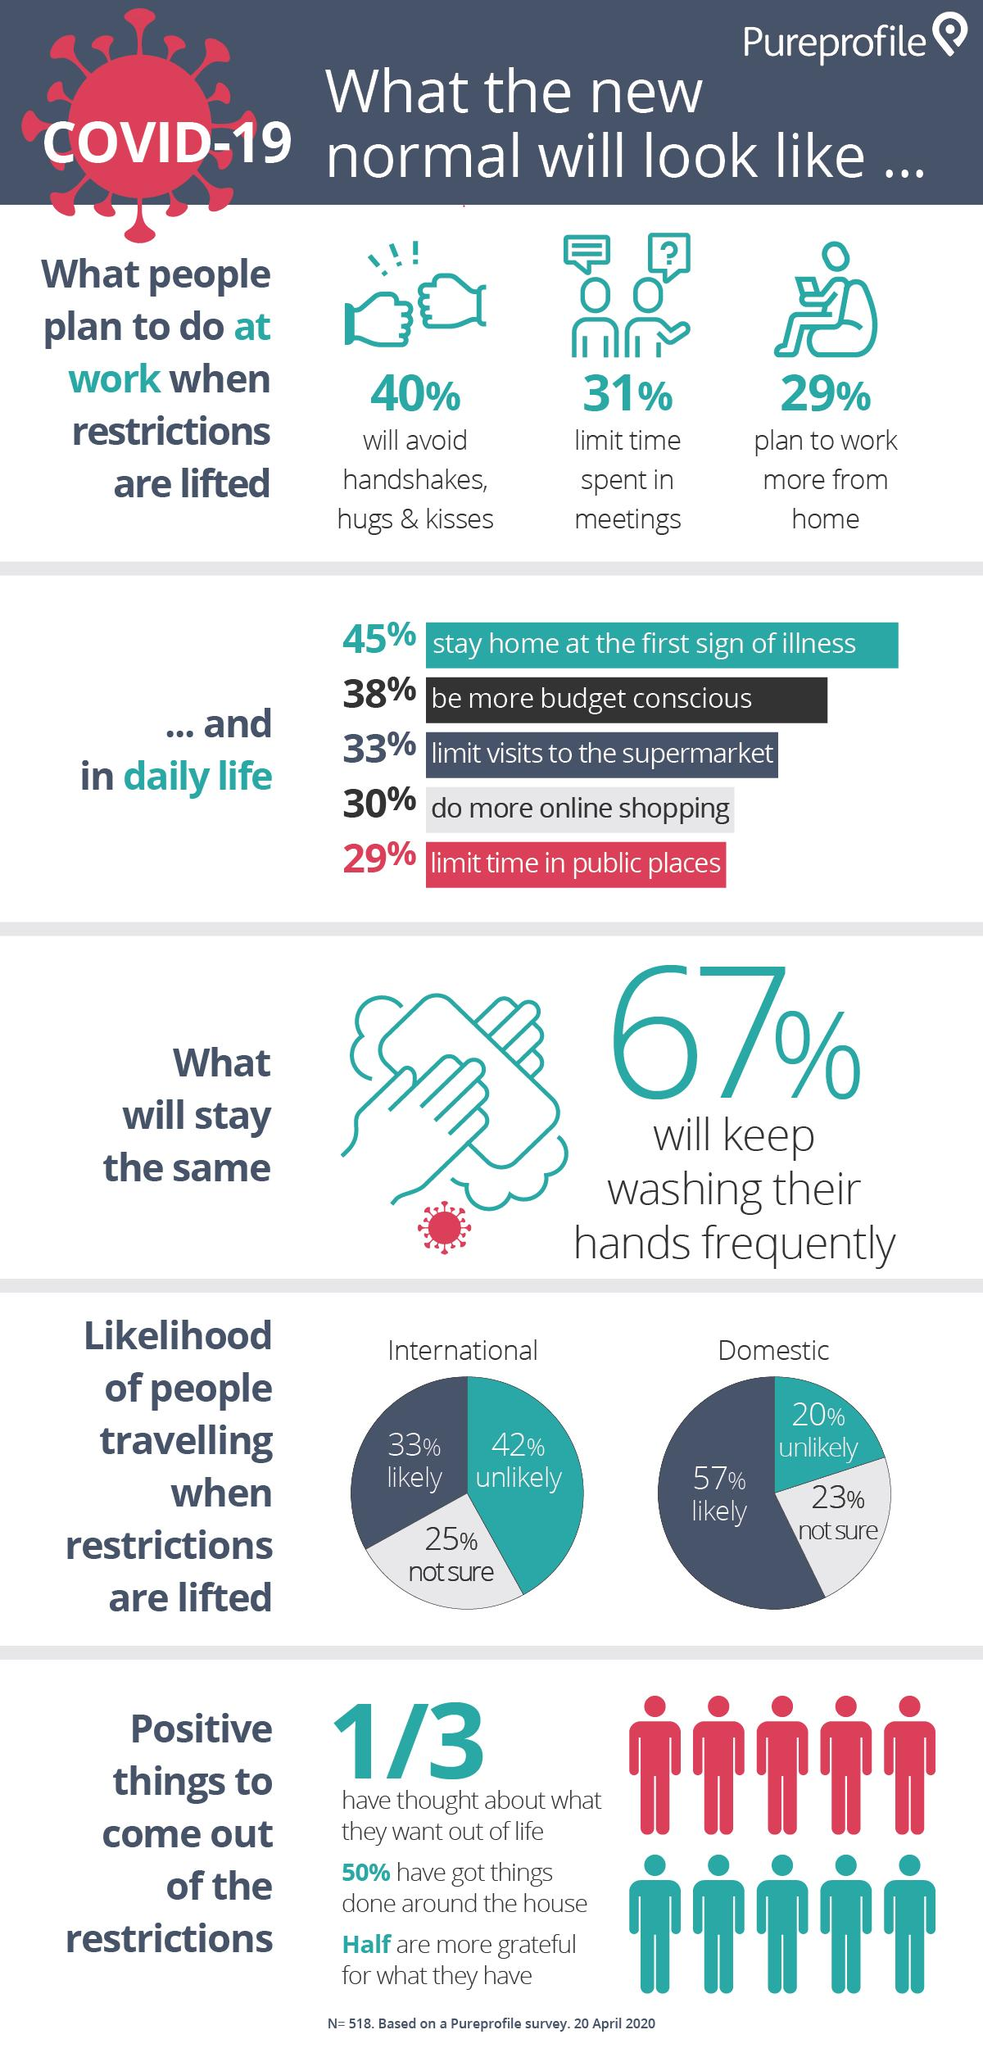List a handful of essential elements in this visual. According to a recent survey, 29% of people plan to work more from home in the future. A large majority of people, approximately 70%, prefer offline shopping. The results of the study showed that the percentage of "likely" is highest in domestic travel compared to international travel. A significant proportion of people, approximately 40%, avoid handshakes, hugs, and kisses. There are five individuals in this infographic who are categorized as red. 